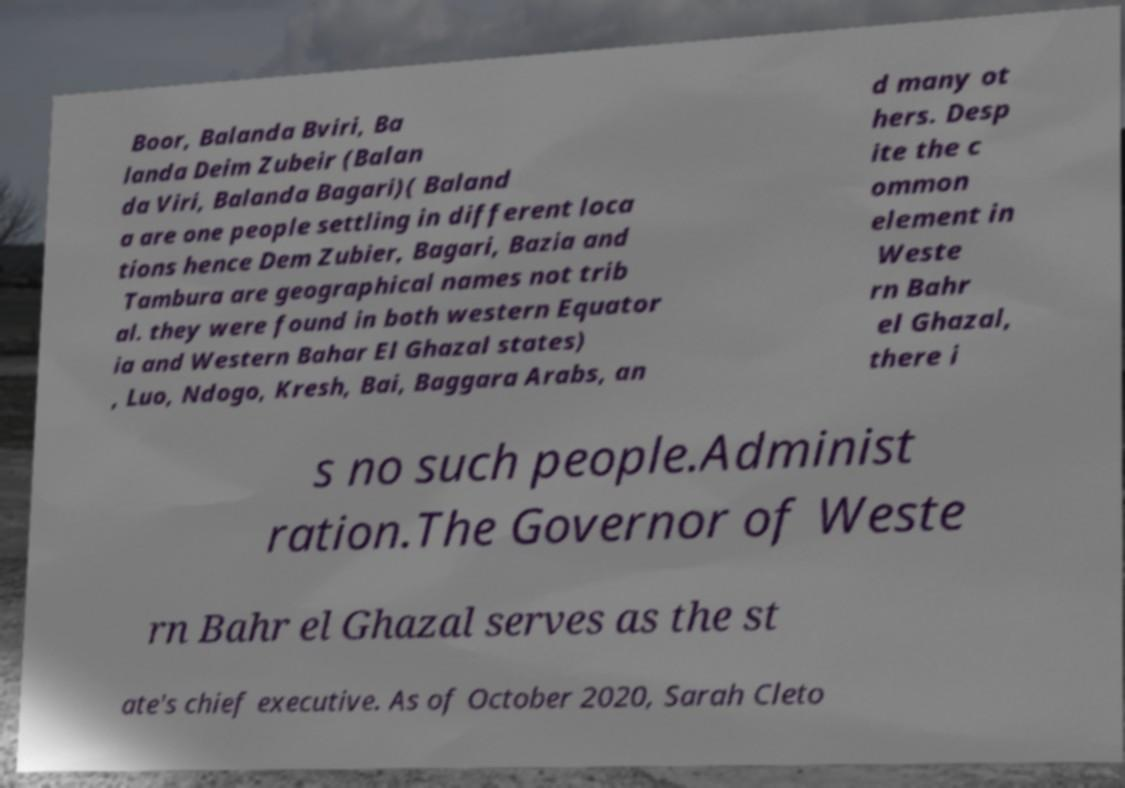Could you extract and type out the text from this image? Boor, Balanda Bviri, Ba landa Deim Zubeir (Balan da Viri, Balanda Bagari)( Baland a are one people settling in different loca tions hence Dem Zubier, Bagari, Bazia and Tambura are geographical names not trib al. they were found in both western Equator ia and Western Bahar El Ghazal states) , Luo, Ndogo, Kresh, Bai, Baggara Arabs, an d many ot hers. Desp ite the c ommon element in Weste rn Bahr el Ghazal, there i s no such people.Administ ration.The Governor of Weste rn Bahr el Ghazal serves as the st ate's chief executive. As of October 2020, Sarah Cleto 